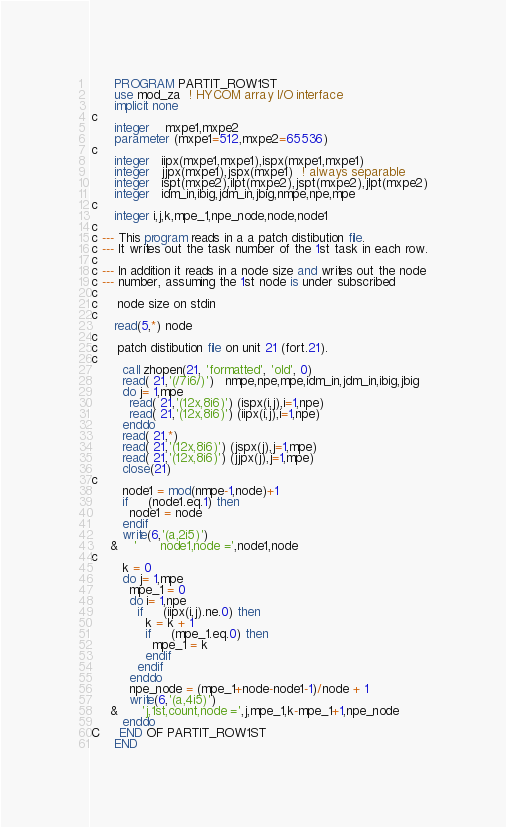Convert code to text. <code><loc_0><loc_0><loc_500><loc_500><_FORTRAN_>      PROGRAM PARTIT_ROW1ST
      use mod_za  ! HYCOM array I/O interface
      implicit none
c
      integer    mxpe1,mxpe2
      parameter (mxpe1=512,mxpe2=65536)
c
      integer   iipx(mxpe1,mxpe1),ispx(mxpe1,mxpe1)
      integer   jjpx(mxpe1),jspx(mxpe1)  ! always separable
      integer   ispt(mxpe2),ilpt(mxpe2),jspt(mxpe2),jlpt(mxpe2)
      integer   idm_in,ibig,jdm_in,jbig,nmpe,npe,mpe
c
      integer i,j,k,mpe_1,npe_node,node,node1
c
c --- This program reads in a a patch distibution file.
c --- It writes out the task number of the 1st task in each row.
c
c --- In addition it reads in a node size and writes out the node
c --- number, assuming the 1st node is under subscribed
c
c     node size on stdin
c
      read(5,*) node
c
c     patch distibution file on unit 21 (fort.21).
c
        call zhopen(21, 'formatted', 'old', 0)
        read( 21,'(/7i6/)')   nmpe,npe,mpe,idm_in,jdm_in,ibig,jbig
        do j= 1,mpe
          read( 21,'(12x,8i6)') (ispx(i,j),i=1,npe)
          read( 21,'(12x,8i6)') (iipx(i,j),i=1,npe)
        enddo
        read( 21,*)
        read( 21,'(12x,8i6)') (jspx(j),j=1,mpe)
        read( 21,'(12x,8i6)') (jjpx(j),j=1,mpe)
        close(21)
c
        node1 = mod(nmpe-1,node)+1
        if     (node1.eq.1) then
          node1 = node
        endif
        write(6,'(a,2i5)') 
     &    '      node1,node =',node1,node
c
        k = 0
        do j= 1,mpe
          mpe_1 = 0
          do i= 1,npe
            if     (iipx(i,j).ne.0) then
              k = k + 1
              if     (mpe_1.eq.0) then
                mpe_1 = k
              endif
            endif
          enddo
          npe_node = (mpe_1+node-node1-1)/node + 1
          write(6,'(a,4i5)') 
     &      'j,1st,count,node =',j,mpe_1,k-mpe_1+1,npe_node
        enddo
C     END OF PARTIT_ROW1ST
      END
</code> 